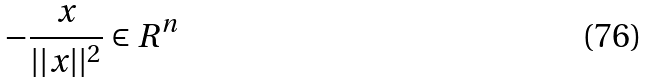Convert formula to latex. <formula><loc_0><loc_0><loc_500><loc_500>- \frac { x } { | | x | | ^ { 2 } } \in R ^ { n }</formula> 